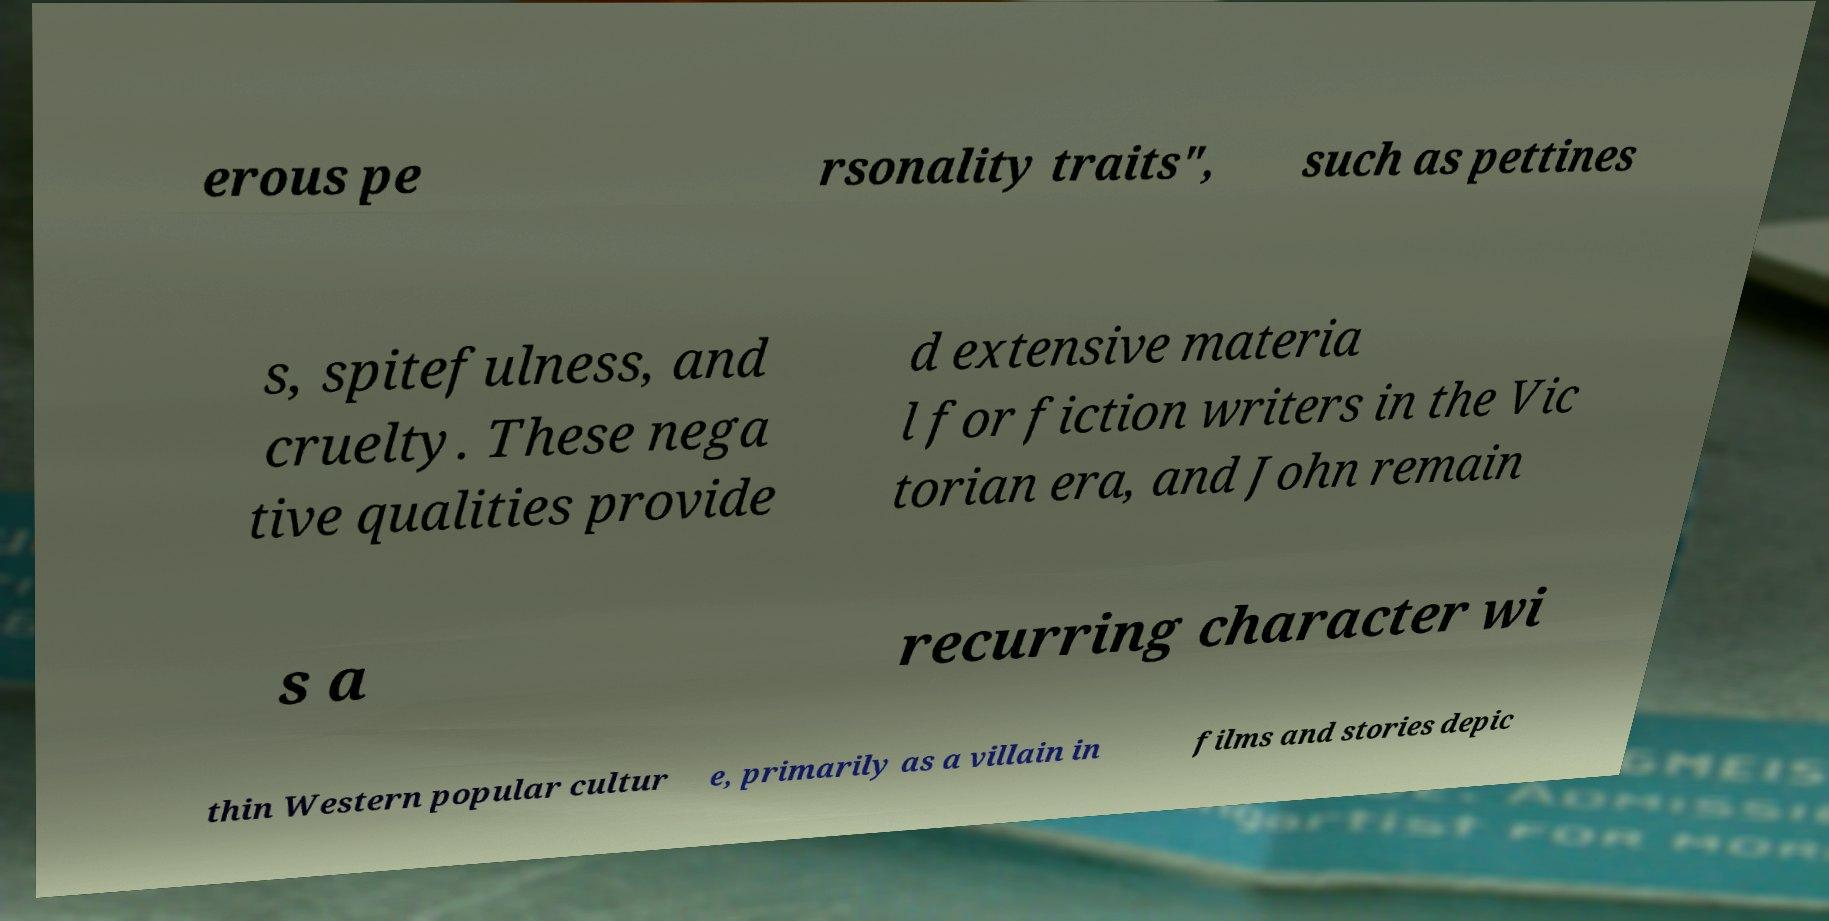I need the written content from this picture converted into text. Can you do that? erous pe rsonality traits", such as pettines s, spitefulness, and cruelty. These nega tive qualities provide d extensive materia l for fiction writers in the Vic torian era, and John remain s a recurring character wi thin Western popular cultur e, primarily as a villain in films and stories depic 